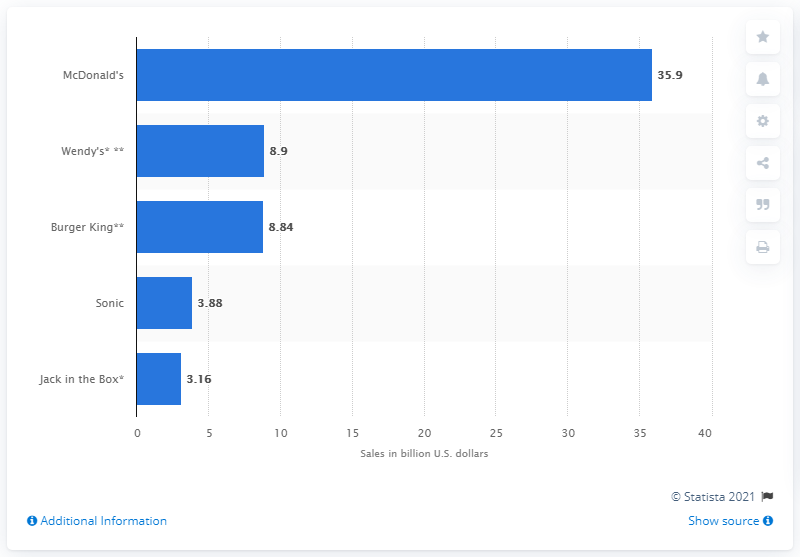Give some essential details in this illustration. In 2013, Wendy's reported sales of 8.9 billion dollars. McDonald's made a total of 35.9 billion U.S. dollars in revenue in 2013. 